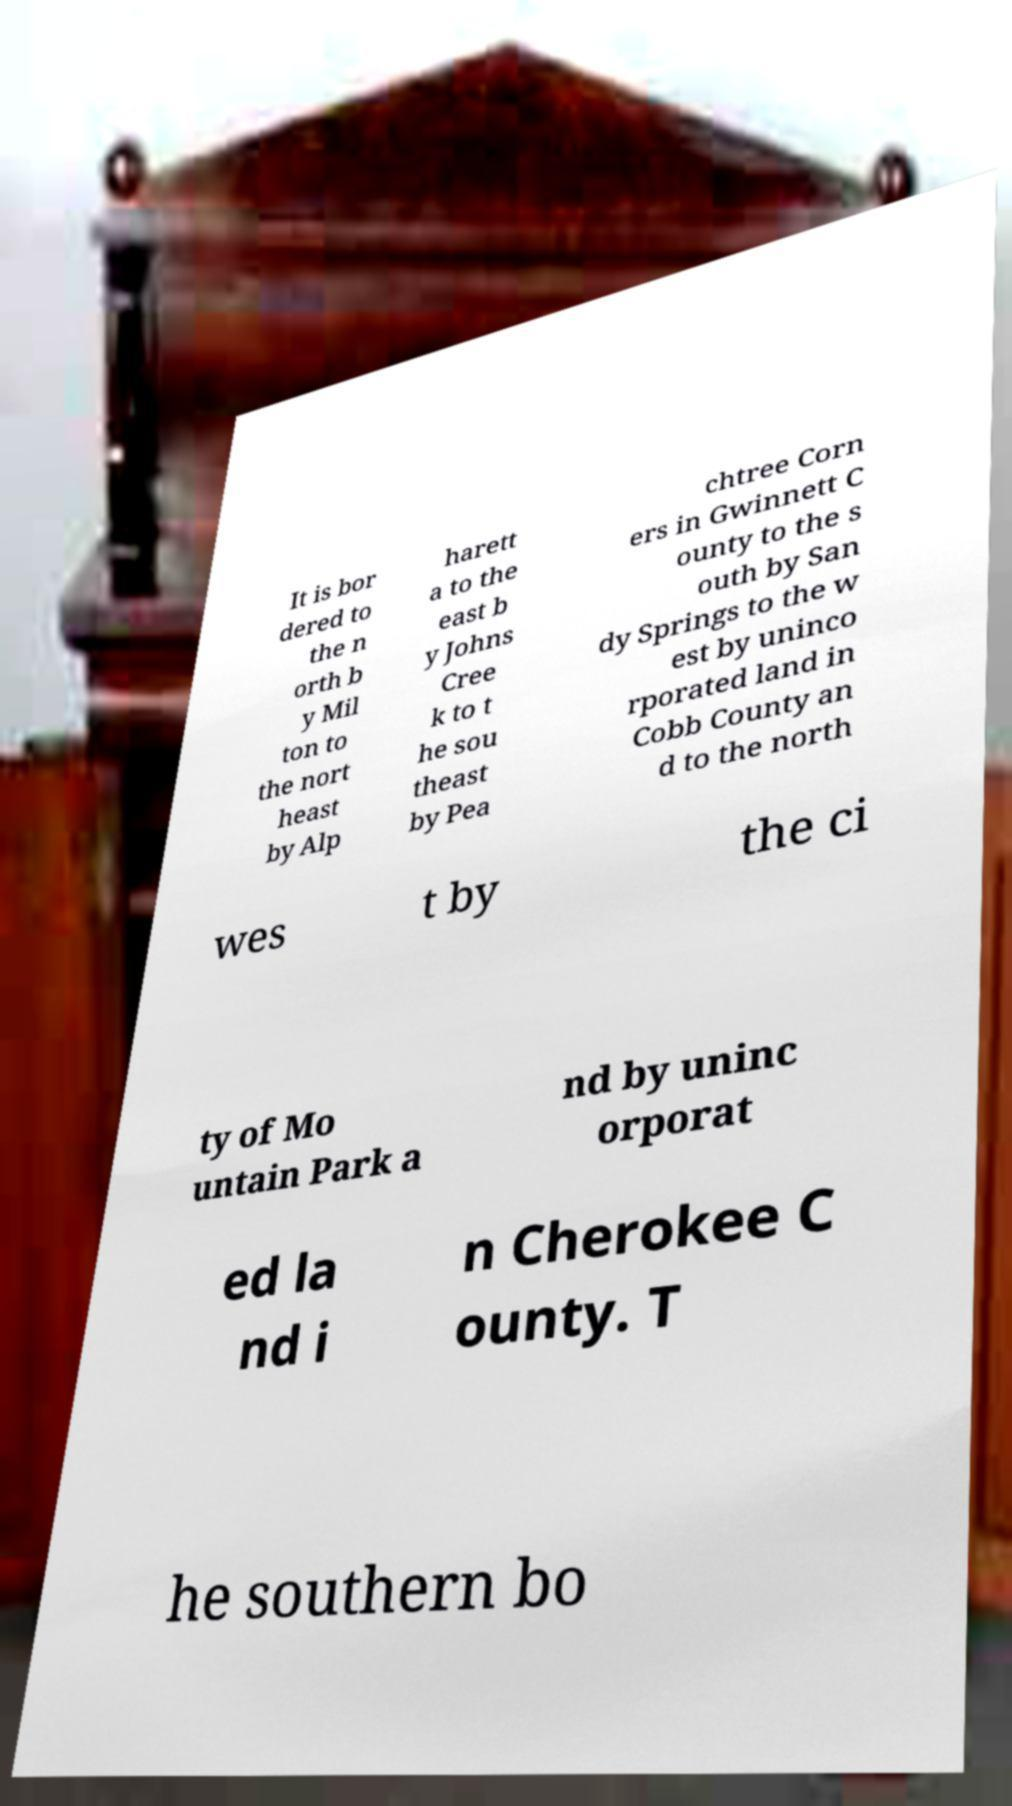Could you extract and type out the text from this image? It is bor dered to the n orth b y Mil ton to the nort heast by Alp harett a to the east b y Johns Cree k to t he sou theast by Pea chtree Corn ers in Gwinnett C ounty to the s outh by San dy Springs to the w est by uninco rporated land in Cobb County an d to the north wes t by the ci ty of Mo untain Park a nd by uninc orporat ed la nd i n Cherokee C ounty. T he southern bo 